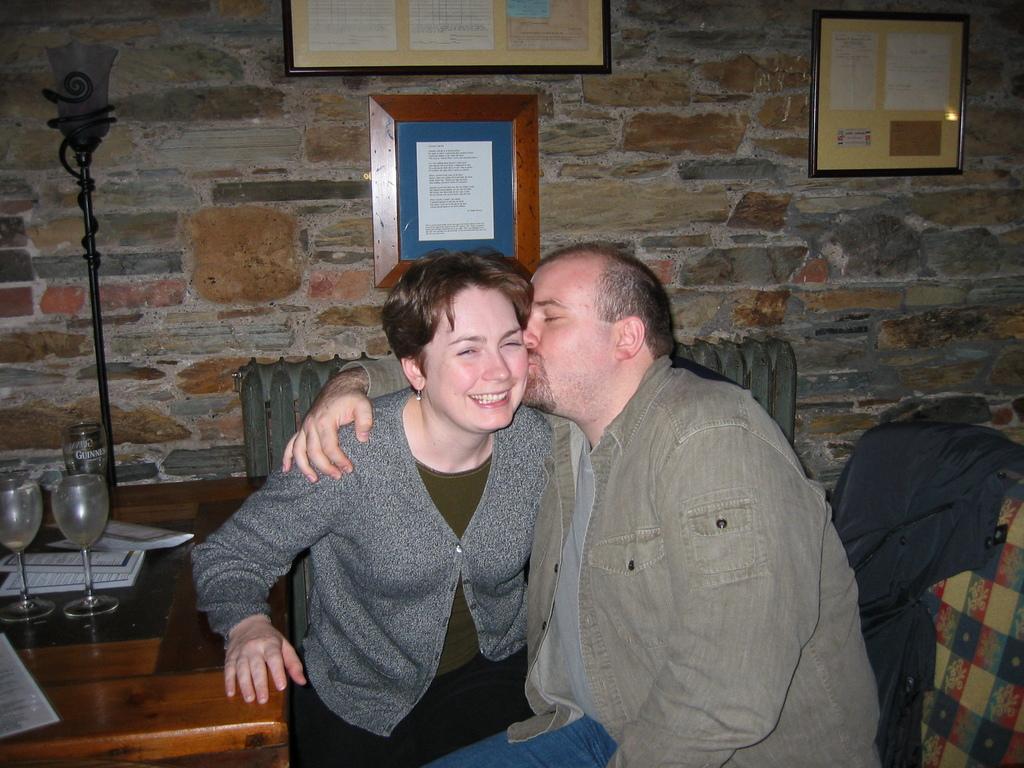Could you give a brief overview of what you see in this image? There is a man and woman in this picture. The man is kissing the woman on her cheeks. Both of them were sitting in the chair in front of a table on which some books and wine glasses were placed. In the background there is a lamp and a pole. We can observe some photo frames attached to the wall here. 